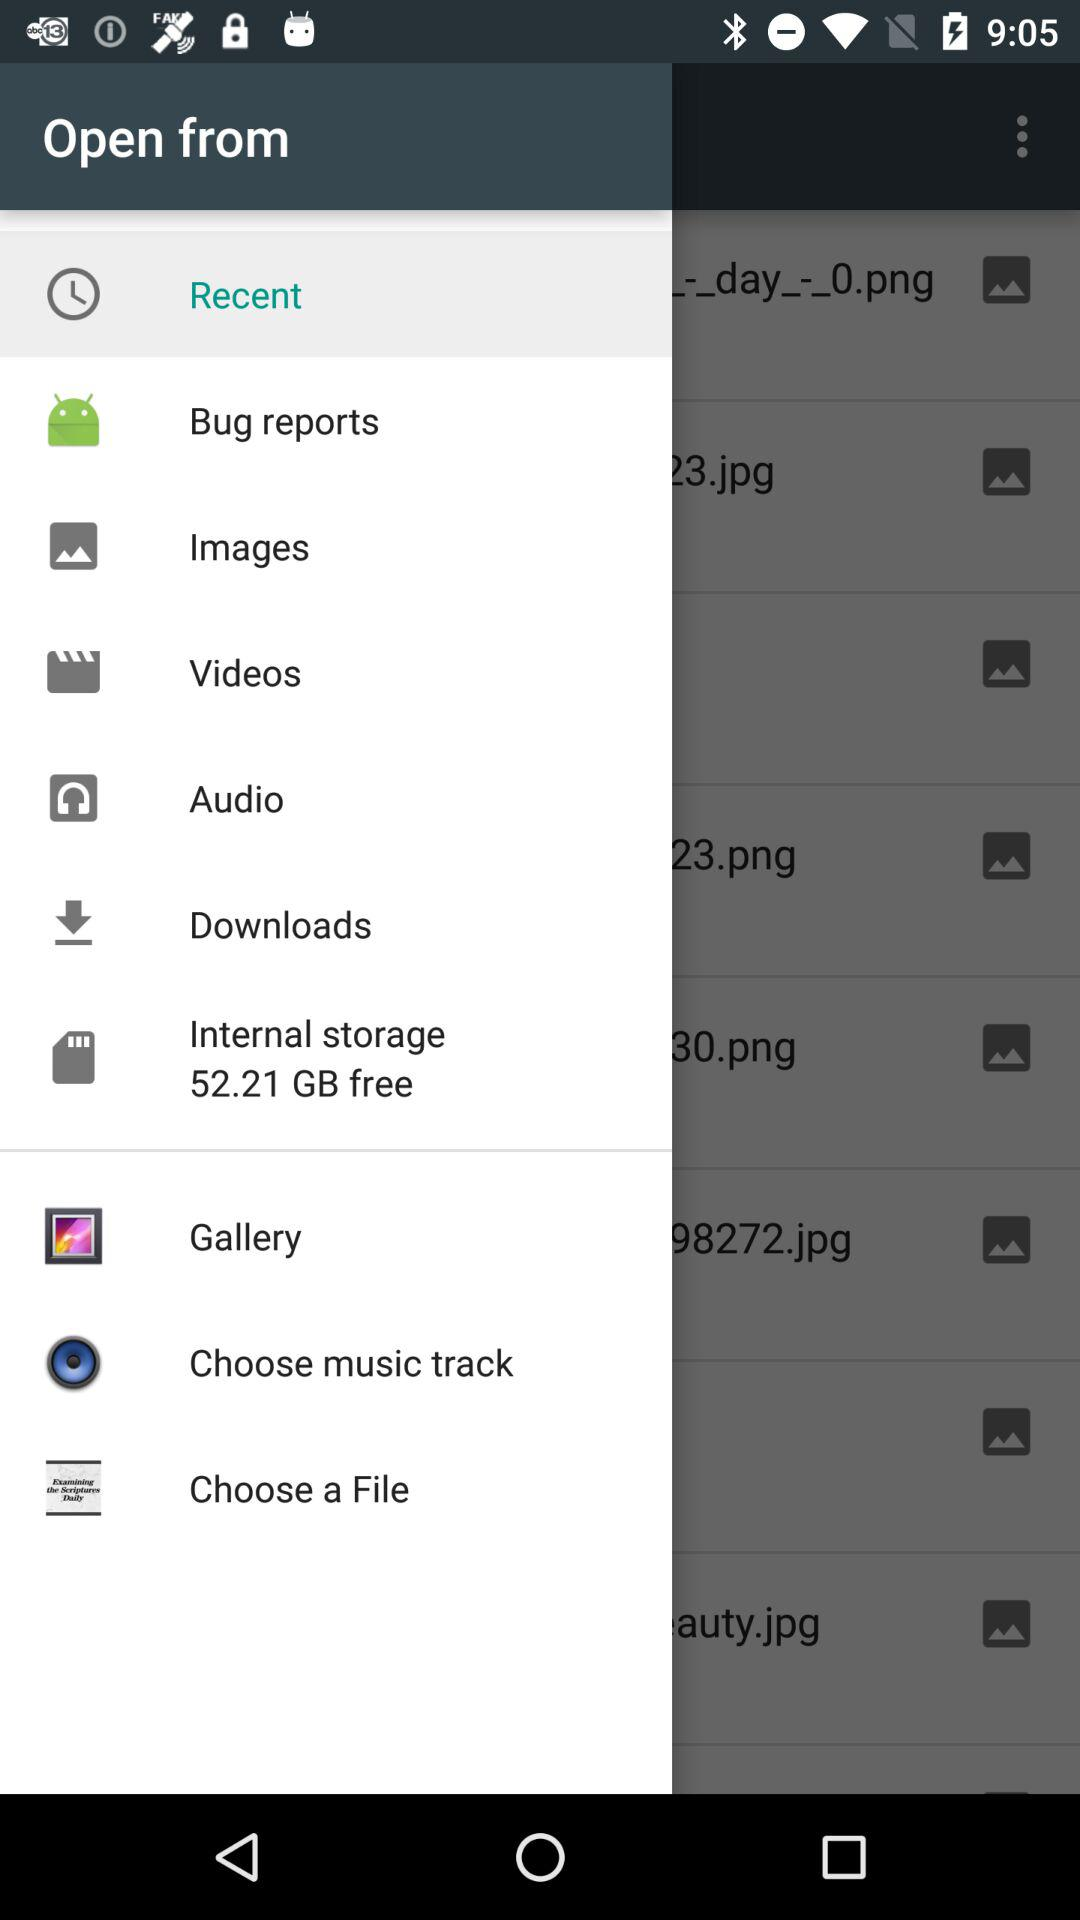How much free storage is there? The free storage is 52.21 GB. 